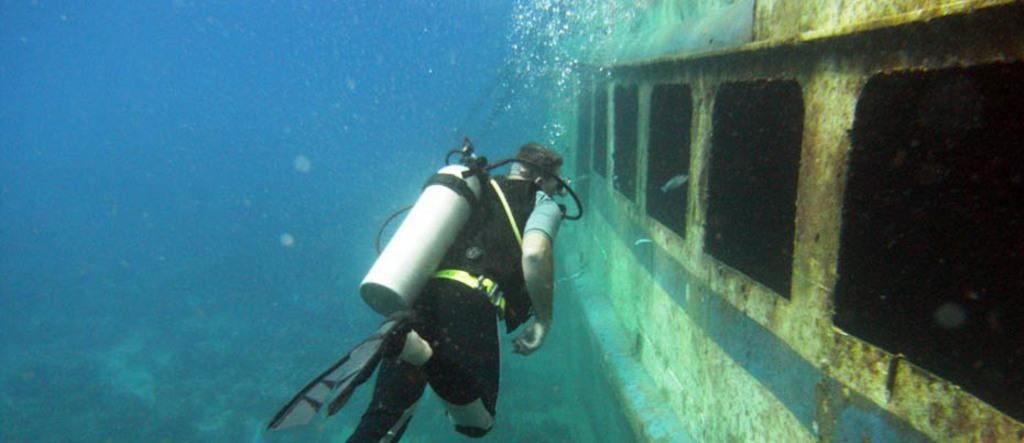Please provide a concise description of this image. This image is taken in the sea. In the middle of the image a man is scuba diving in the sea. He has worn an oxygen mask and diving fins. There is an oxygen cylinder on his shoulder. On the right side of the image there is a ship under the sea. 